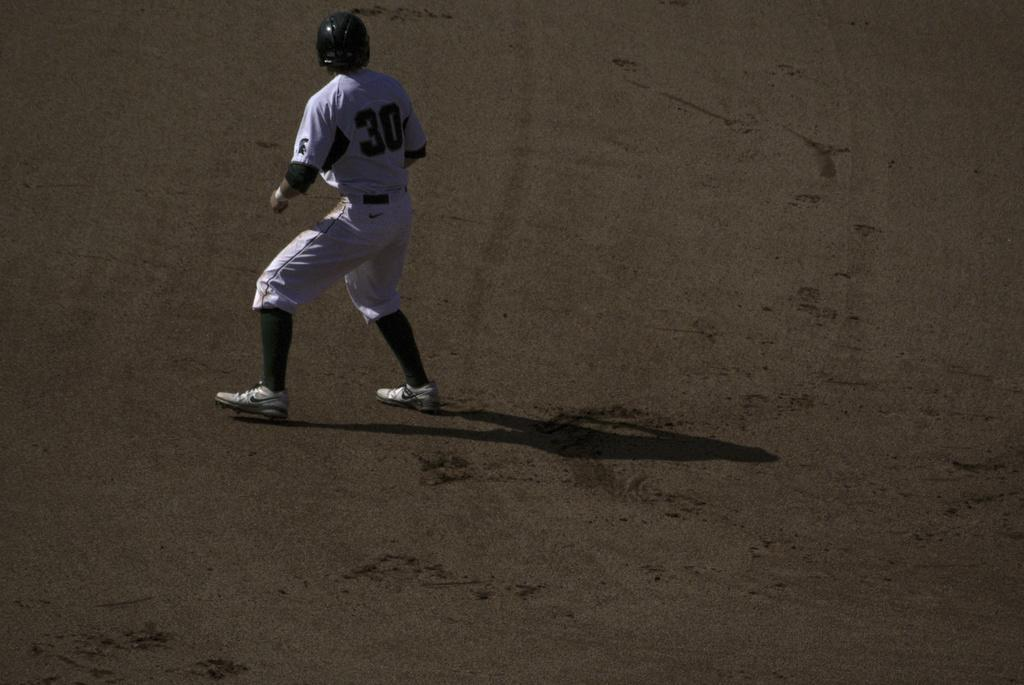Who is present in the image? There is a man in the image. What is the man doing in the image? The man is standing on a path. Can you describe any additional details about the man's presence in the image? The man's shadow is visible on the path. What type of division is taking place in the image? There is no division present in the image; it features a man standing on a path with his shadow visible. 